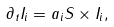<formula> <loc_0><loc_0><loc_500><loc_500>\partial _ { t } { I } _ { i } = a _ { i } { S } \times { I } _ { i } ,</formula> 